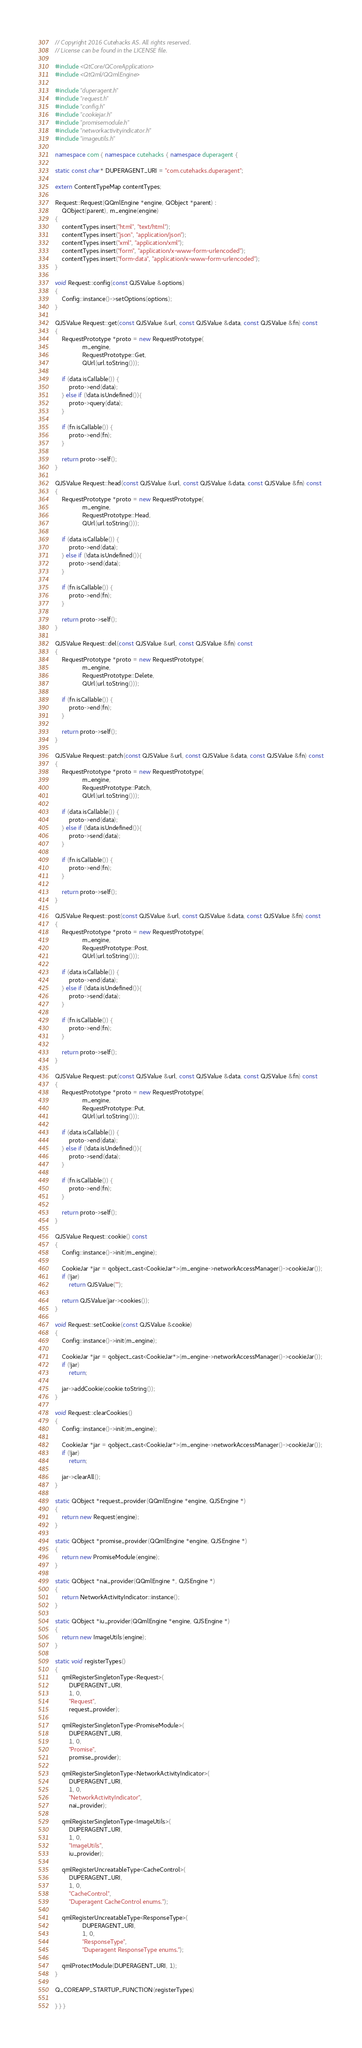<code> <loc_0><loc_0><loc_500><loc_500><_C++_>// Copyright 2016 Cutehacks AS. All rights reserved.
// License can be found in the LICENSE file.

#include <QtCore/QCoreApplication>
#include <QtQml/QQmlEngine>

#include "duperagent.h"
#include "request.h"
#include "config.h"
#include "cookiejar.h"
#include "promisemodule.h"
#include "networkactivityindicator.h"
#include "imageutils.h"

namespace com { namespace cutehacks { namespace duperagent {

static const char* DUPERAGENT_URI = "com.cutehacks.duperagent";

extern ContentTypeMap contentTypes;

Request::Request(QQmlEngine *engine, QObject *parent) :
    QObject(parent), m_engine(engine)
{
    contentTypes.insert("html", "text/html");
    contentTypes.insert("json", "application/json");
    contentTypes.insert("xml", "application/xml");
    contentTypes.insert("form", "application/x-www-form-urlencoded");
    contentTypes.insert("form-data", "application/x-www-form-urlencoded");
}

void Request::config(const QJSValue &options)
{
    Config::instance()->setOptions(options);
}

QJSValue Request::get(const QJSValue &url, const QJSValue &data, const QJSValue &fn) const
{
    RequestPrototype *proto = new RequestPrototype(
                m_engine,
                RequestPrototype::Get,
                QUrl(url.toString()));

    if (data.isCallable()) {
        proto->end(data);
    } else if (!data.isUndefined()){
        proto->query(data);
    }

    if (fn.isCallable()) {
        proto->end(fn);
    }

    return proto->self();
}

QJSValue Request::head(const QJSValue &url, const QJSValue &data, const QJSValue &fn) const
{
    RequestPrototype *proto = new RequestPrototype(
                m_engine,
                RequestPrototype::Head,
                QUrl(url.toString()));

    if (data.isCallable()) {
        proto->end(data);
    } else if (!data.isUndefined()){
        proto->send(data);
    }

    if (fn.isCallable()) {
        proto->end(fn);
    }

    return proto->self();
}

QJSValue Request::del(const QJSValue &url, const QJSValue &fn) const
{
    RequestPrototype *proto = new RequestPrototype(
                m_engine,
                RequestPrototype::Delete,
                QUrl(url.toString()));

    if (fn.isCallable()) {
        proto->end(fn);
    }

    return proto->self();
}

QJSValue Request::patch(const QJSValue &url, const QJSValue &data, const QJSValue &fn) const
{
    RequestPrototype *proto = new RequestPrototype(
                m_engine,
                RequestPrototype::Patch,
                QUrl(url.toString()));

    if (data.isCallable()) {
        proto->end(data);
    } else if (!data.isUndefined()){
        proto->send(data);
    }

    if (fn.isCallable()) {
        proto->end(fn);
    }

    return proto->self();
}

QJSValue Request::post(const QJSValue &url, const QJSValue &data, const QJSValue &fn) const
{
    RequestPrototype *proto = new RequestPrototype(
                m_engine,
                RequestPrototype::Post,
                QUrl(url.toString()));

    if (data.isCallable()) {
        proto->end(data);
    } else if (!data.isUndefined()){
        proto->send(data);
    }

    if (fn.isCallable()) {
        proto->end(fn);
    }

    return proto->self();
}

QJSValue Request::put(const QJSValue &url, const QJSValue &data, const QJSValue &fn) const
{
    RequestPrototype *proto = new RequestPrototype(
                m_engine,
                RequestPrototype::Put,
                QUrl(url.toString()));

    if (data.isCallable()) {
        proto->end(data);
    } else if (!data.isUndefined()){
        proto->send(data);
    }

    if (fn.isCallable()) {
        proto->end(fn);
    }

    return proto->self();
}

QJSValue Request::cookie() const
{
    Config::instance()->init(m_engine);

    CookieJar *jar = qobject_cast<CookieJar*>(m_engine->networkAccessManager()->cookieJar());
    if (!jar)
        return QJSValue("");

    return QJSValue(jar->cookies());
}

void Request::setCookie(const QJSValue &cookie)
{
    Config::instance()->init(m_engine);

    CookieJar *jar = qobject_cast<CookieJar*>(m_engine->networkAccessManager()->cookieJar());
    if (!jar)
        return;

    jar->addCookie(cookie.toString());
}

void Request::clearCookies()
{
    Config::instance()->init(m_engine);

    CookieJar *jar = qobject_cast<CookieJar*>(m_engine->networkAccessManager()->cookieJar());
    if (!jar)
        return;

    jar->clearAll();
}

static QObject *request_provider(QQmlEngine *engine, QJSEngine *)
{
    return new Request(engine);
}

static QObject *promise_provider(QQmlEngine *engine, QJSEngine *)
{
    return new PromiseModule(engine);
}

static QObject *nai_provider(QQmlEngine *, QJSEngine *)
{
    return NetworkActivityIndicator::instance();
}

static QObject *iu_provider(QQmlEngine *engine, QJSEngine *)
{
    return new ImageUtils(engine);
}

static void registerTypes()
{
    qmlRegisterSingletonType<Request>(
        DUPERAGENT_URI,
        1, 0,
        "Request",
        request_provider);

    qmlRegisterSingletonType<PromiseModule>(
        DUPERAGENT_URI,
        1, 0,
        "Promise",
        promise_provider);

    qmlRegisterSingletonType<NetworkActivityIndicator>(
        DUPERAGENT_URI,
        1, 0,
        "NetworkActivityIndicator",
        nai_provider);

    qmlRegisterSingletonType<ImageUtils>(
        DUPERAGENT_URI,
        1, 0,
        "ImageUtils",
        iu_provider);

    qmlRegisterUncreatableType<CacheControl>(
        DUPERAGENT_URI,
        1, 0,
        "CacheControl",
        "Duperagent CacheControl enums.");

    qmlRegisterUncreatableType<ResponseType>(
                DUPERAGENT_URI,
                1, 0,
                "ResponseType",
                "Duperagent ResponseType enums.");

    qmlProtectModule(DUPERAGENT_URI, 1);
}

Q_COREAPP_STARTUP_FUNCTION(registerTypes)

} } }
</code> 